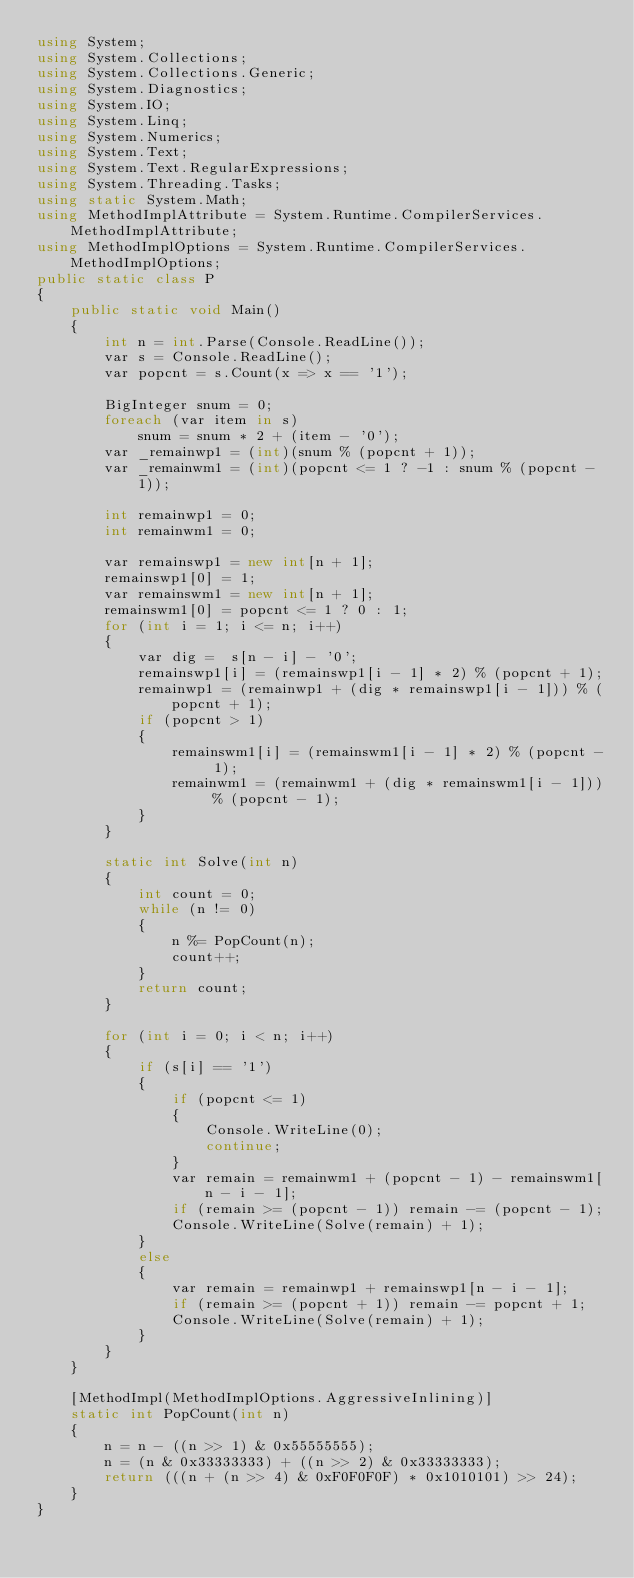<code> <loc_0><loc_0><loc_500><loc_500><_C#_>using System;
using System.Collections;
using System.Collections.Generic;
using System.Diagnostics;
using System.IO;
using System.Linq;
using System.Numerics;
using System.Text;
using System.Text.RegularExpressions;
using System.Threading.Tasks;
using static System.Math;
using MethodImplAttribute = System.Runtime.CompilerServices.MethodImplAttribute;
using MethodImplOptions = System.Runtime.CompilerServices.MethodImplOptions;
public static class P
{
    public static void Main()
    {
        int n = int.Parse(Console.ReadLine());
        var s = Console.ReadLine();
        var popcnt = s.Count(x => x == '1');

        BigInteger snum = 0;
        foreach (var item in s)
            snum = snum * 2 + (item - '0');
        var _remainwp1 = (int)(snum % (popcnt + 1));
        var _remainwm1 = (int)(popcnt <= 1 ? -1 : snum % (popcnt - 1));

        int remainwp1 = 0;
        int remainwm1 = 0;

        var remainswp1 = new int[n + 1];
        remainswp1[0] = 1;
        var remainswm1 = new int[n + 1];
        remainswm1[0] = popcnt <= 1 ? 0 : 1;
        for (int i = 1; i <= n; i++)
        {
            var dig =  s[n - i] - '0';
            remainswp1[i] = (remainswp1[i - 1] * 2) % (popcnt + 1);
            remainwp1 = (remainwp1 + (dig * remainswp1[i - 1])) % (popcnt + 1);
            if (popcnt > 1)
            {
                remainswm1[i] = (remainswm1[i - 1] * 2) % (popcnt - 1);
                remainwm1 = (remainwm1 + (dig * remainswm1[i - 1])) % (popcnt - 1);
            }
        }

        static int Solve(int n)
        {
            int count = 0;
            while (n != 0)
            {
                n %= PopCount(n);
                count++;
            }
            return count;
        }

        for (int i = 0; i < n; i++)
        {
            if (s[i] == '1')
            {
                if (popcnt <= 1)
                {
                    Console.WriteLine(0);
                    continue;
                }
                var remain = remainwm1 + (popcnt - 1) - remainswm1[n - i - 1];
                if (remain >= (popcnt - 1)) remain -= (popcnt - 1);
                Console.WriteLine(Solve(remain) + 1);
            }
            else
            {
                var remain = remainwp1 + remainswp1[n - i - 1];
                if (remain >= (popcnt + 1)) remain -= popcnt + 1;
                Console.WriteLine(Solve(remain) + 1);
            }
        }
    }

    [MethodImpl(MethodImplOptions.AggressiveInlining)]
    static int PopCount(int n)
    {
        n = n - ((n >> 1) & 0x55555555);
        n = (n & 0x33333333) + ((n >> 2) & 0x33333333);
        return (((n + (n >> 4) & 0xF0F0F0F) * 0x1010101) >> 24);
    }
}
</code> 